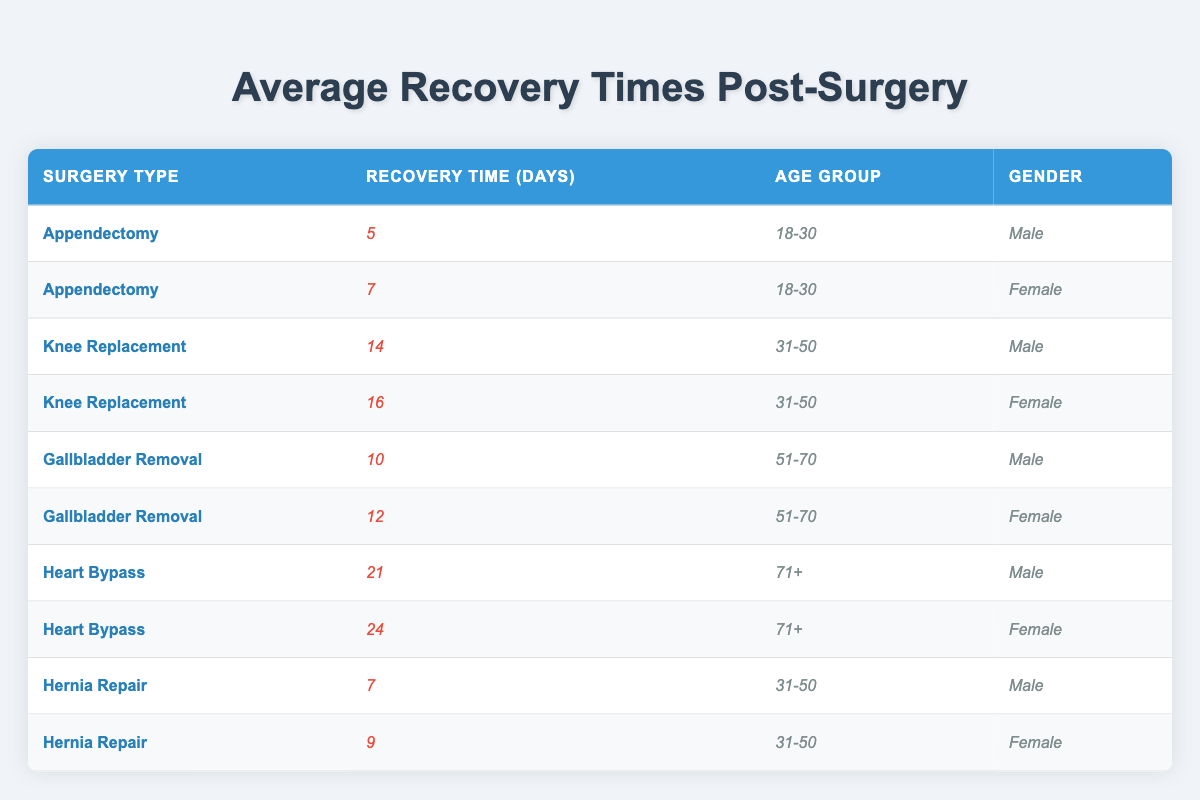What is the average recovery time for male patients aged 18-30 after an appendectomy? The table shows that the average recovery time for male patients aged 18-30 who had an appendectomy is 5 days.
Answer: 5 days What is the average recovery time for female patients aged 51-70 after gallbladder removal? According to the table, the average recovery time for female patients aged 51-70 who had gallbladder removal is 12 days.
Answer: 12 days Which surgery type has the longest average recovery time for male patients? The longest average recovery time for male patients is after heart bypass surgery, which takes 21 days.
Answer: Heart bypass What is the difference in average recovery time between male and female patients aged 31-50 after knee replacement surgery? For male patients, the average recovery time is 14 days, and for female patients, it is 16 days. The difference is 16 - 14 = 2 days.
Answer: 2 days Are female patients generally expected to have a longer recovery time than male patients across all surgery types? The data shows varying results: female patients have longer recovery times for appendectomy, knee replacement, gallbladder removal, and heart bypass, but not in hernia repair where males are shorter. Thus, it is not consistent.
Answer: No What is the total recovery time for all male patients after hernia repair? The average recovery time for male patients after hernia repair is 7 days. Since there is only one entry for this group, the total is 7 days.
Answer: 7 days Which age group experiences the longest average recovery time after heart bypass surgery? The table indicates that patients aged 71+ have the longest average recovery time after heart bypass surgery, at 21 days for males and 24 days for females.
Answer: 24 days for females How would you summarize the recovery times for the 18-30 age group based on the table? For the 18-30 age group, male patients have an average recovery of 5 days for appendectomy, and female patients have an average of 7 days for appendectomy; so, the overall average for this group is (5 + 7) / 2 = 6 days.
Answer: 6 days What is the average recovery time for all surgeries combined for female patients? The recovery times for female patients are: 7 days (appendectomy) + 16 days (knee replacement) + 12 days (gallbladder removal) + 24 days (heart bypass) + 9 days (hernia repair), summing to 68 days. There are 5 surgery types, so the average is 68/5 = 13.6 days.
Answer: 13.6 days Is there any type of surgery where males and females have the same average recovery time? The hernia repair shows the same recovery time of 7 days for males and 9 days for females, but they are not equal. Therefore, there is no surgery type with equal recovery times.
Answer: No 